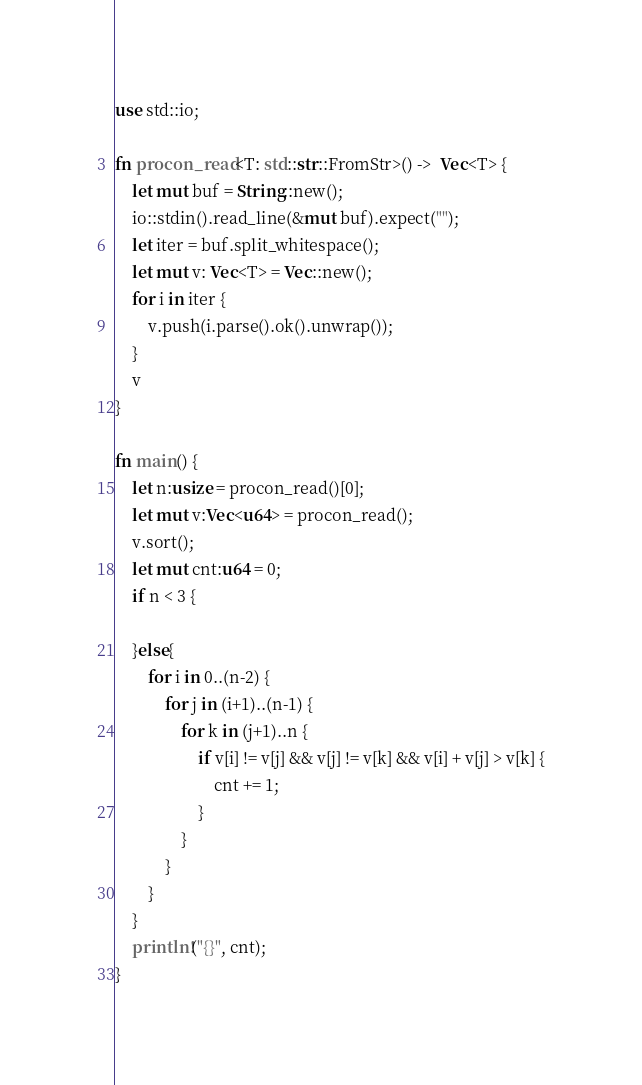<code> <loc_0><loc_0><loc_500><loc_500><_Rust_>use std::io;

fn procon_read<T: std::str::FromStr>() ->  Vec<T> {
    let mut buf = String::new();
    io::stdin().read_line(&mut buf).expect("");
    let iter = buf.split_whitespace();
    let mut v: Vec<T> = Vec::new();
    for i in iter {
        v.push(i.parse().ok().unwrap());
    }
    v
}

fn main() {
    let n:usize = procon_read()[0];
    let mut v:Vec<u64> = procon_read();
    v.sort();
    let mut cnt:u64 = 0;
    if n < 3 {
        
    }else{
        for i in 0..(n-2) {
            for j in (i+1)..(n-1) {
                for k in (j+1)..n {
                    if v[i] != v[j] && v[j] != v[k] && v[i] + v[j] > v[k] {
                        cnt += 1;
                    }
                }
            }
        }
    }
    println!("{}", cnt);
}</code> 